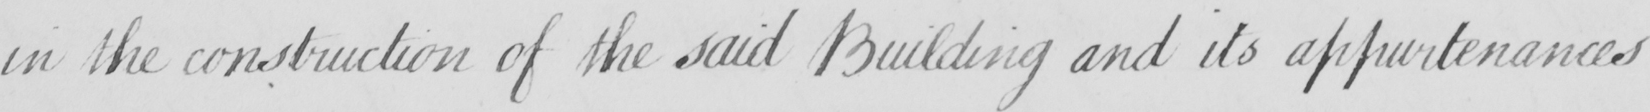What text is written in this handwritten line? in the construction of the said Building and its appurtenances 